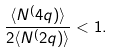Convert formula to latex. <formula><loc_0><loc_0><loc_500><loc_500>\frac { \langle N ^ { ( } 4 q ) \rangle } { 2 \langle N ^ { ( } 2 q ) \rangle } < 1 .</formula> 